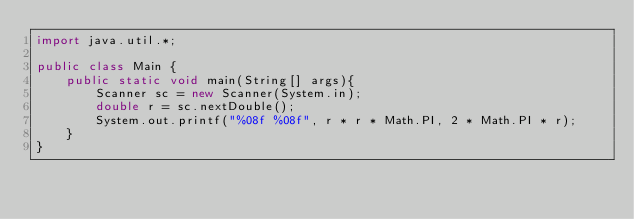Convert code to text. <code><loc_0><loc_0><loc_500><loc_500><_Java_>import java.util.*;

public class Main {
	public static void main(String[] args){
		Scanner sc = new Scanner(System.in);
		double r = sc.nextDouble();
		System.out.printf("%08f %08f", r * r * Math.PI, 2 * Math.PI * r);
	}
}</code> 